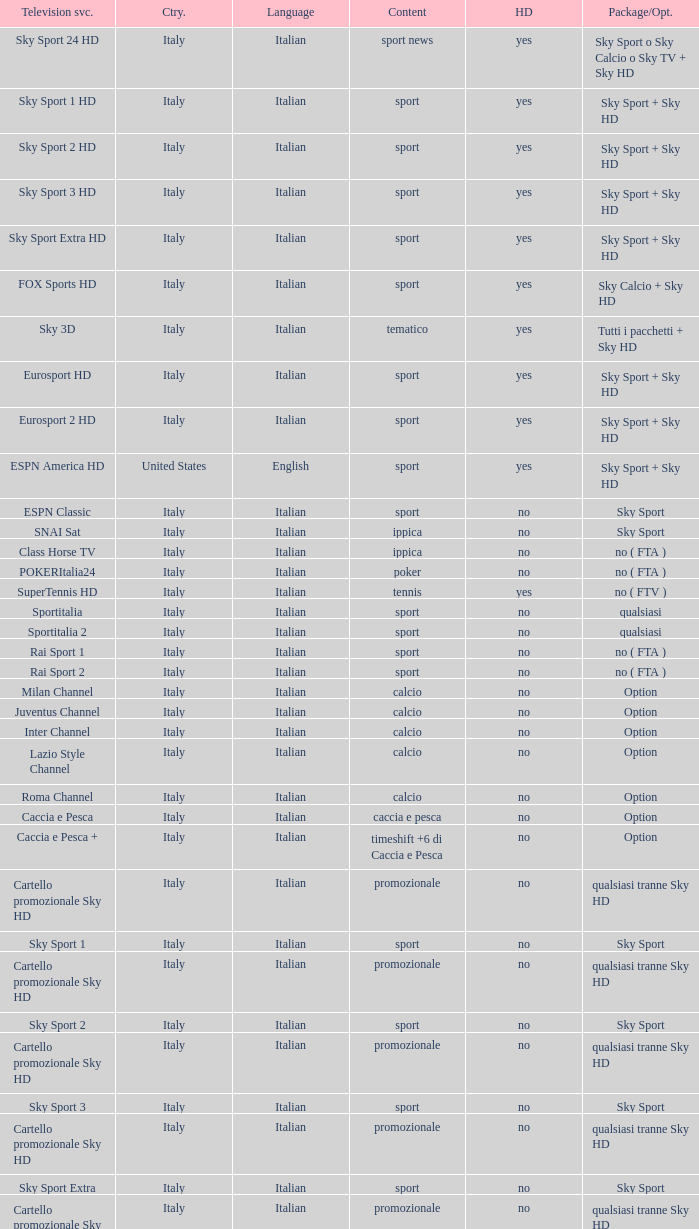What is Package/Option, when Content is Tennis? No ( ftv ). 